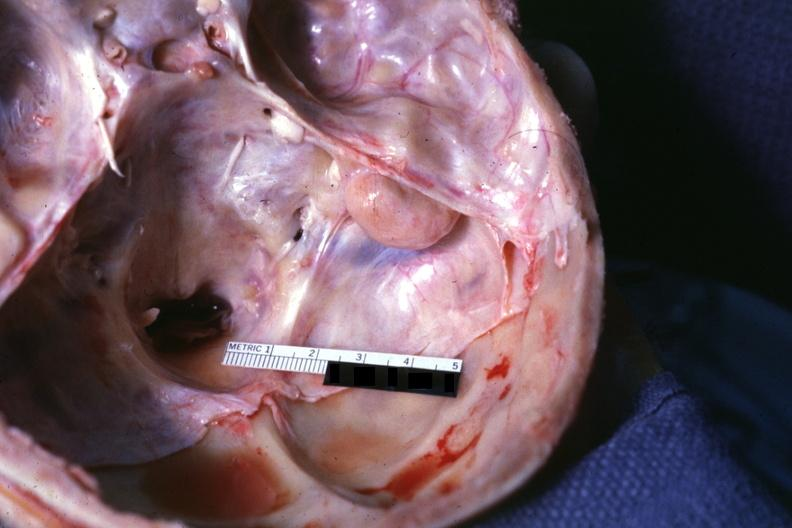what seen on surface right petrous bone?
Answer the question using a single word or phrase. Lesion 